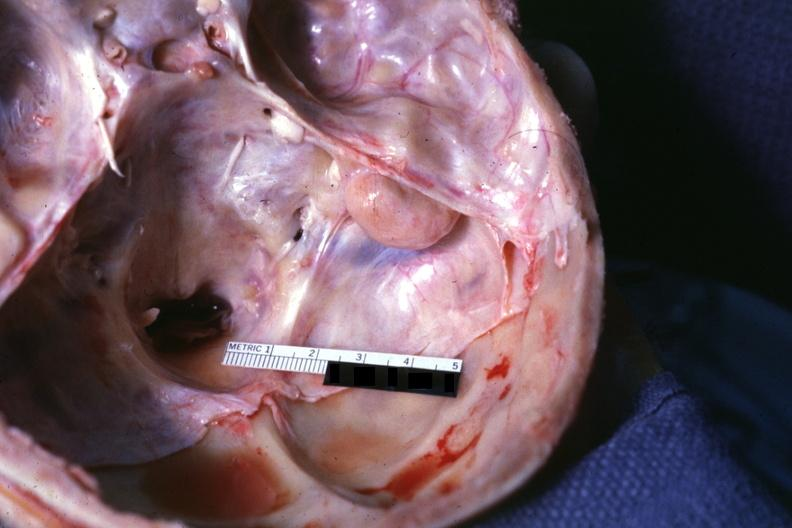what seen on surface right petrous bone?
Answer the question using a single word or phrase. Lesion 